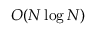Convert formula to latex. <formula><loc_0><loc_0><loc_500><loc_500>O ( N \log N )</formula> 